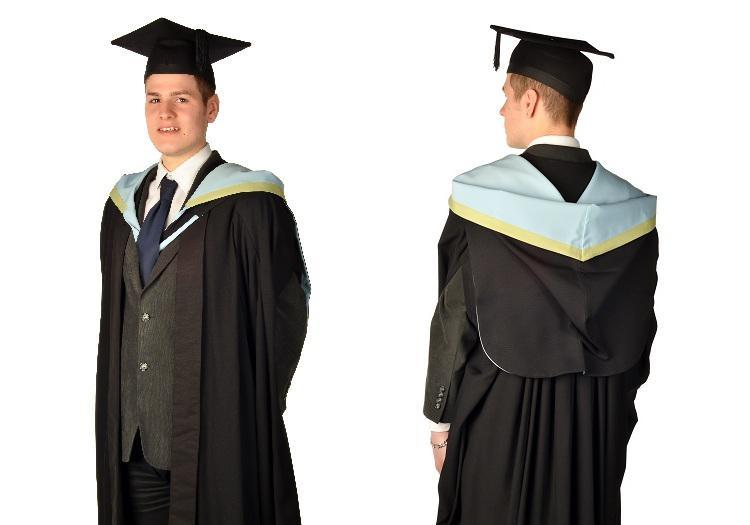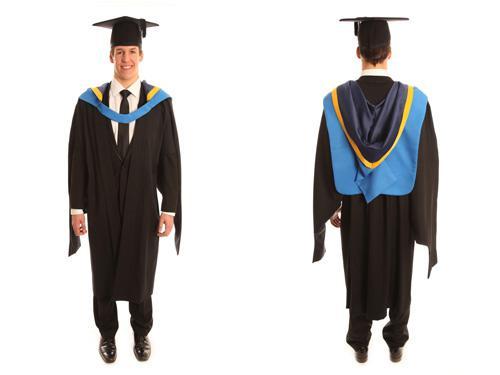The first image is the image on the left, the second image is the image on the right. Analyze the images presented: Is the assertion "All caps and gowns in the images are modeled by actual people who are shown in full length, from head to toe." valid? Answer yes or no. No. The first image is the image on the left, the second image is the image on the right. Assess this claim about the two images: "Each image includes a backward-facing male modeling graduation attire.". Correct or not? Answer yes or no. Yes. 